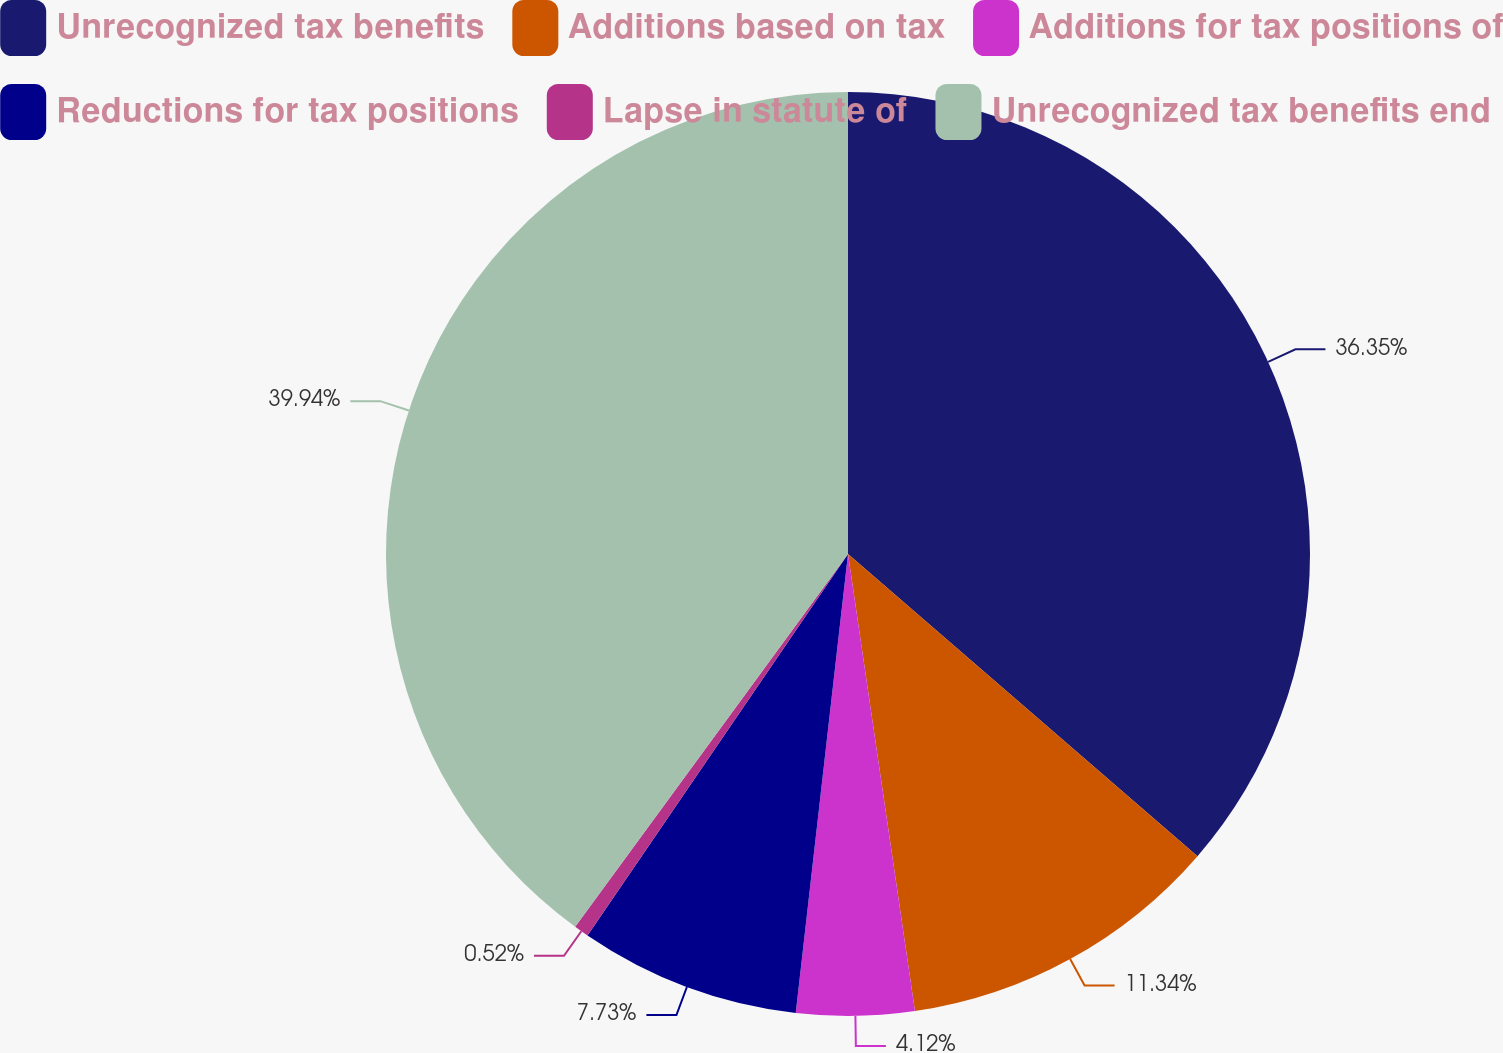Convert chart to OTSL. <chart><loc_0><loc_0><loc_500><loc_500><pie_chart><fcel>Unrecognized tax benefits<fcel>Additions based on tax<fcel>Additions for tax positions of<fcel>Reductions for tax positions<fcel>Lapse in statute of<fcel>Unrecognized tax benefits end<nl><fcel>36.35%<fcel>11.34%<fcel>4.12%<fcel>7.73%<fcel>0.52%<fcel>39.95%<nl></chart> 